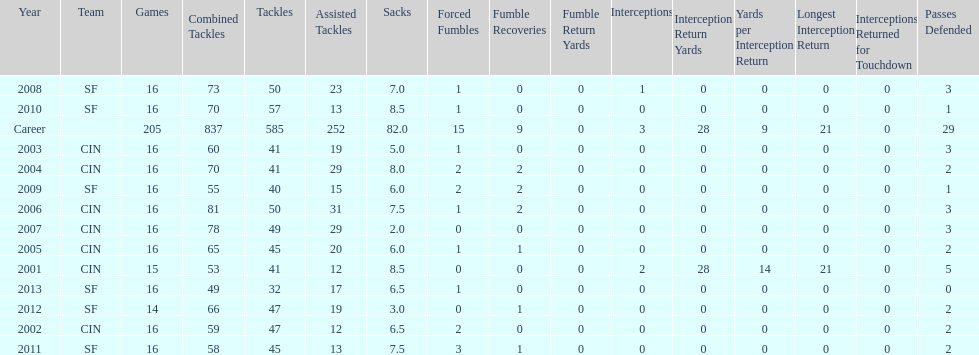How many fumble recoveries did this player have in 2004? 2. 